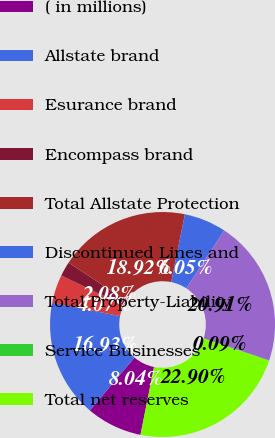Convert chart to OTSL. <chart><loc_0><loc_0><loc_500><loc_500><pie_chart><fcel>( in millions)<fcel>Allstate brand<fcel>Esurance brand<fcel>Encompass brand<fcel>Total Allstate Protection<fcel>Discontinued Lines and<fcel>Total Property-Liability<fcel>Service Businesses<fcel>Total net reserves<nl><fcel>8.04%<fcel>16.93%<fcel>4.07%<fcel>2.08%<fcel>18.92%<fcel>6.05%<fcel>20.91%<fcel>0.09%<fcel>22.9%<nl></chart> 